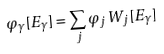<formula> <loc_0><loc_0><loc_500><loc_500>\varphi _ { \gamma } [ E _ { \gamma } ] = \sum _ { j } \varphi _ { j } \, W _ { j } [ E _ { \gamma } ]</formula> 